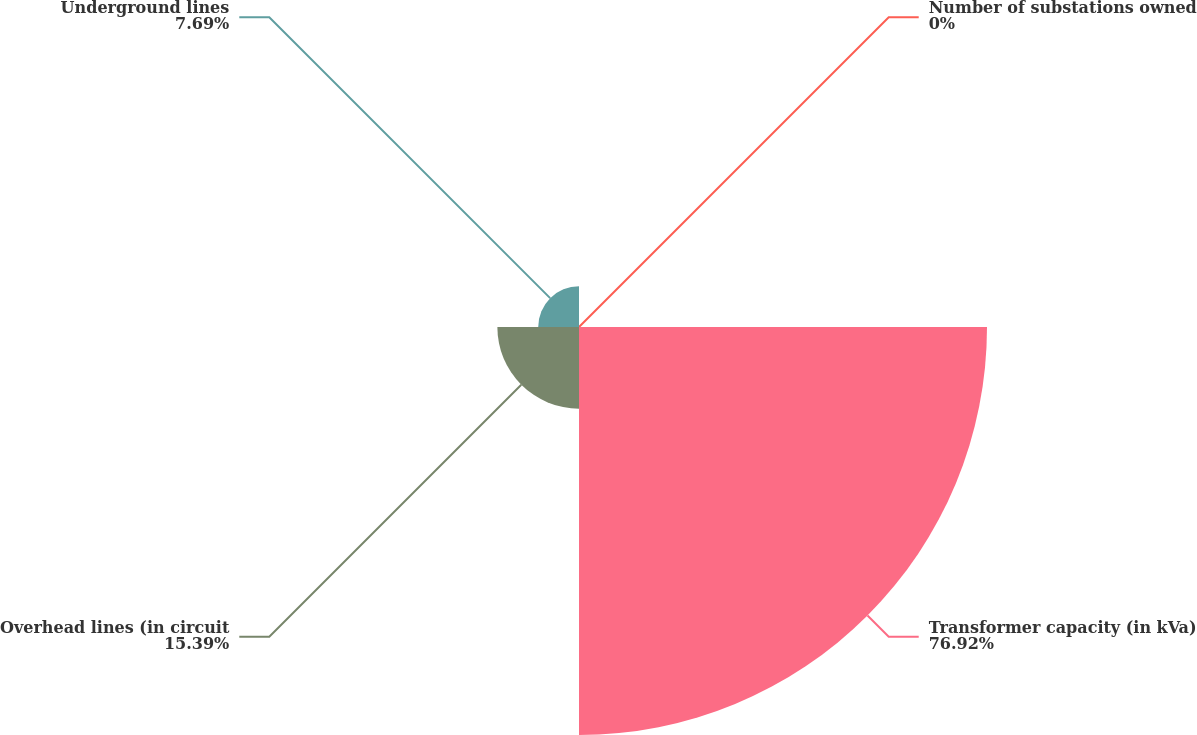Convert chart. <chart><loc_0><loc_0><loc_500><loc_500><pie_chart><fcel>Number of substations owned<fcel>Transformer capacity (in kVa)<fcel>Overhead lines (in circuit<fcel>Underground lines<nl><fcel>0.0%<fcel>76.92%<fcel>15.39%<fcel>7.69%<nl></chart> 